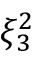<formula> <loc_0><loc_0><loc_500><loc_500>\xi _ { 3 } ^ { 2 }</formula> 